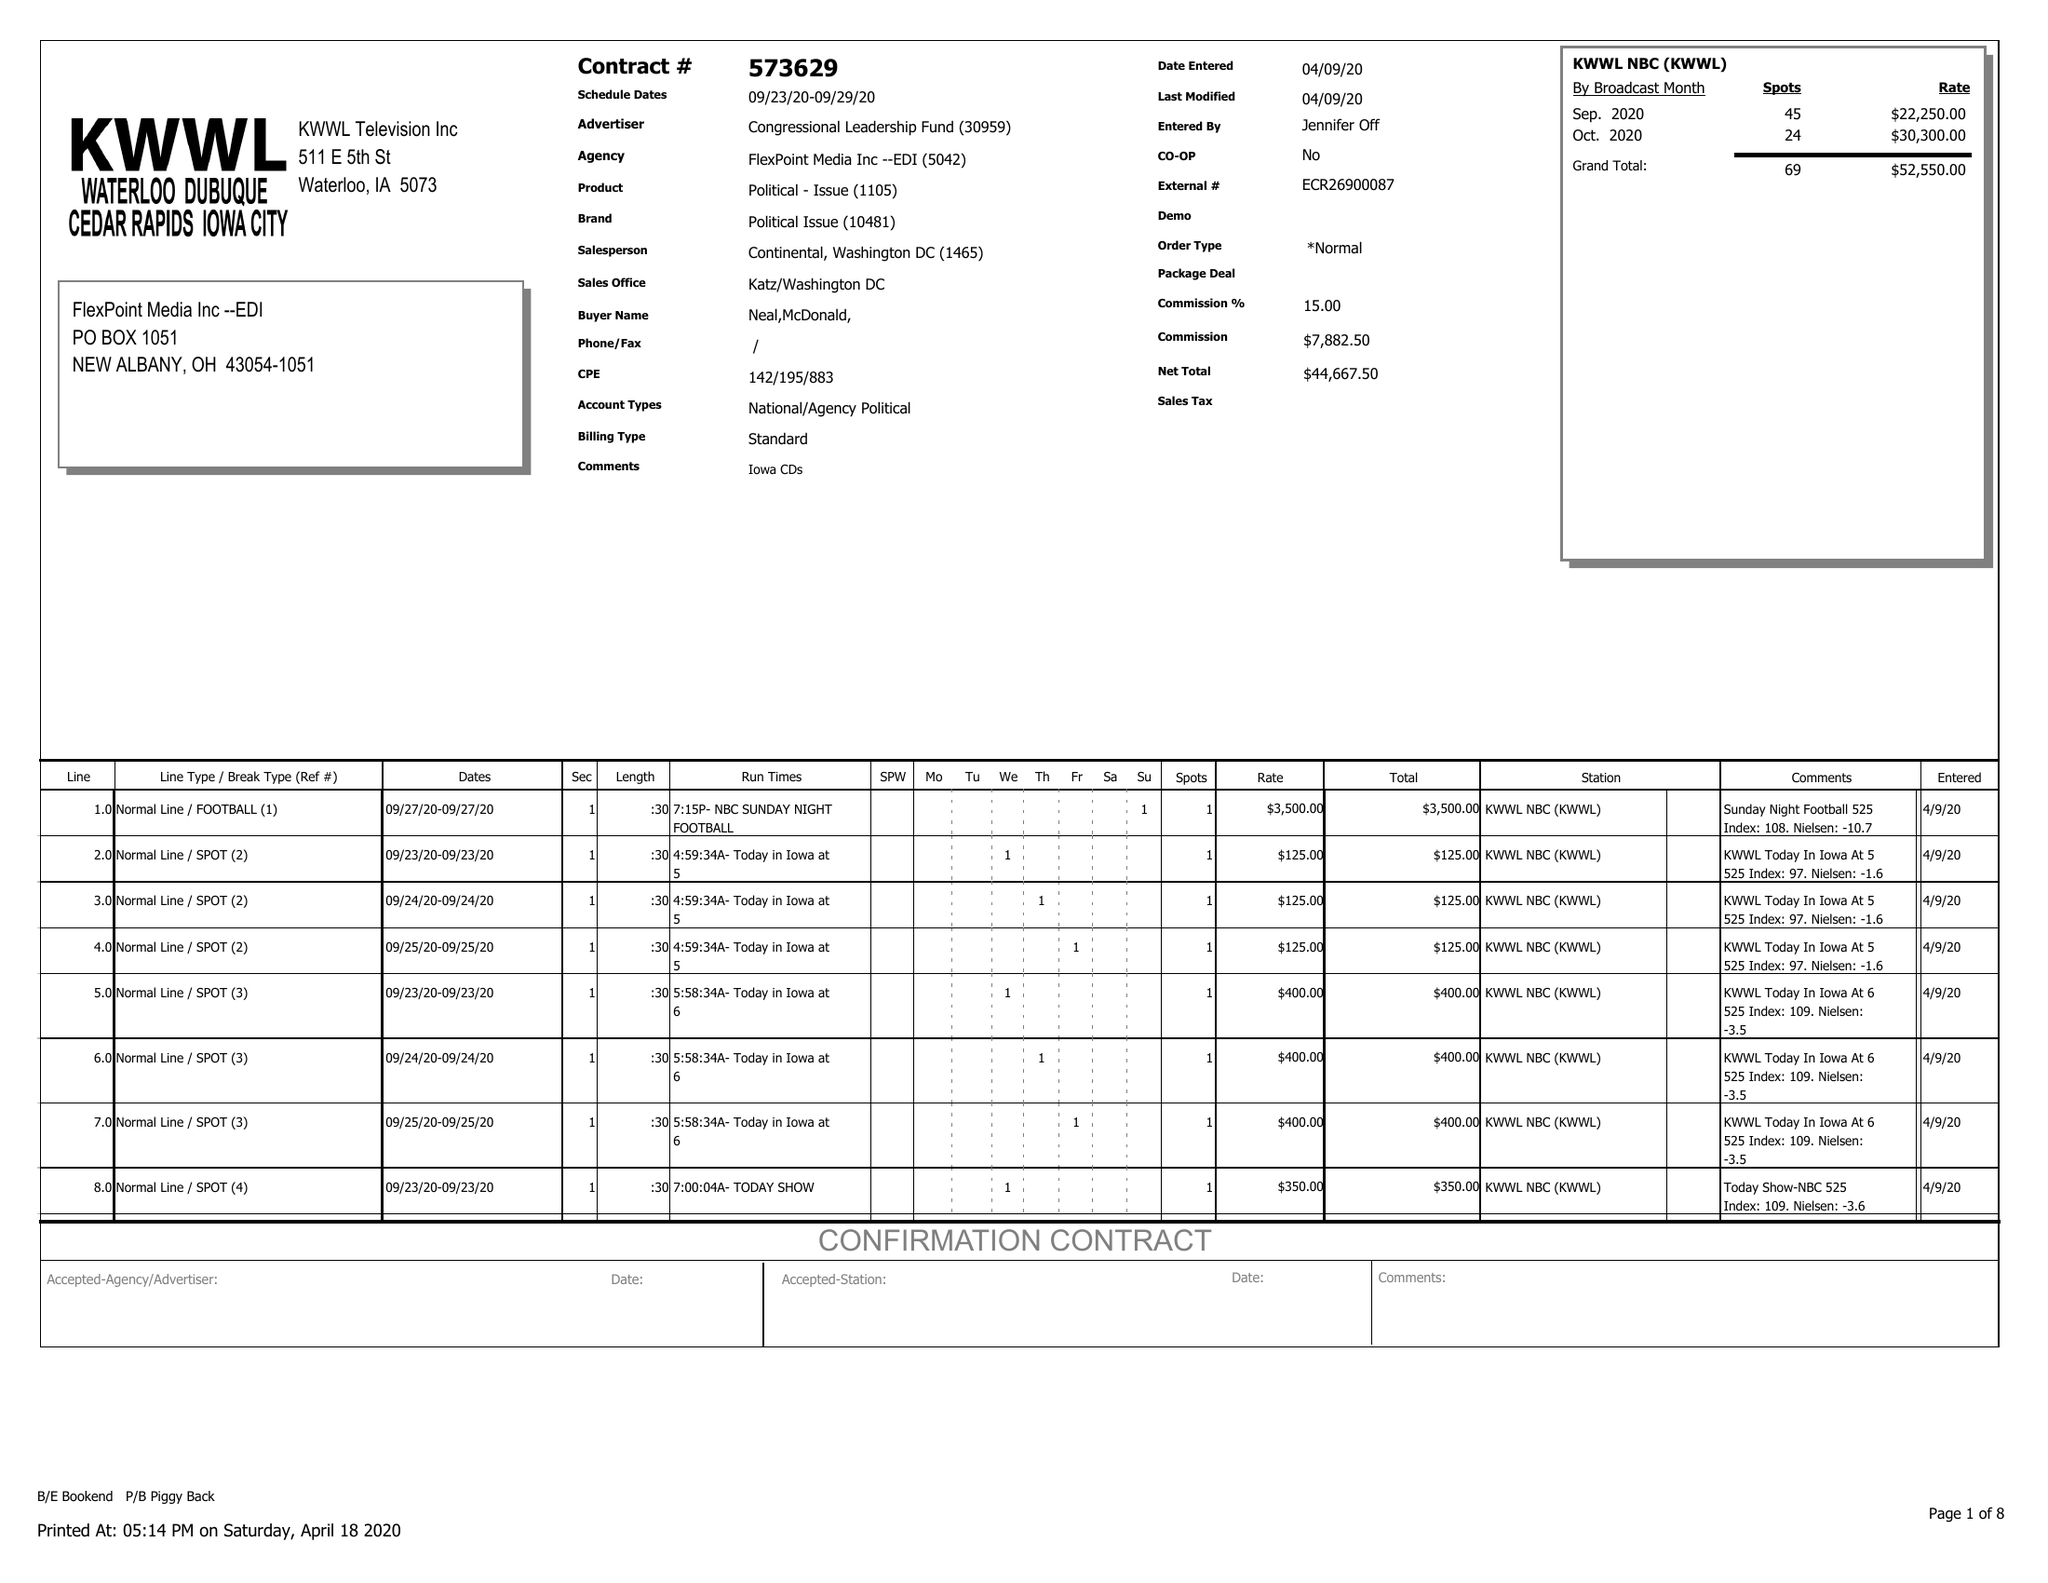What is the value for the gross_amount?
Answer the question using a single word or phrase. 52550.00 